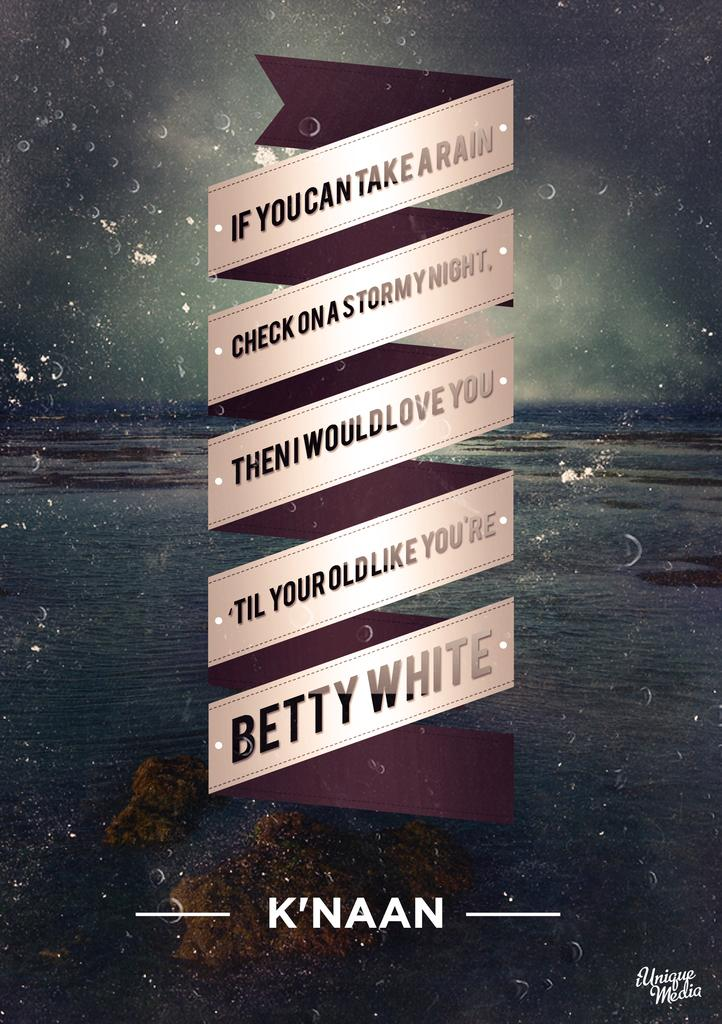Provide a one-sentence caption for the provided image. A poster with a saying about the rain written by Betty White. 